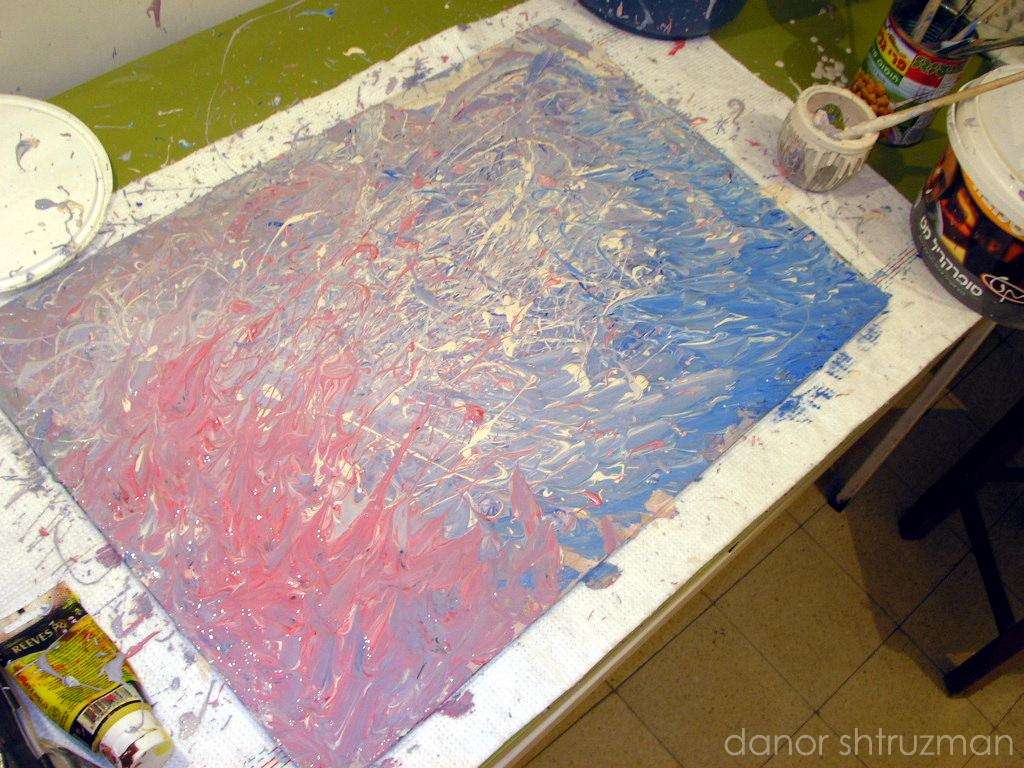What is the main subject of the image? There is a painting on a board in the image. What else can be seen in the image besides the painting? There are objects on a table in the image, and there is a floor visible on the right side bottom of the image. What is located on the right side bottom of the image? There is an object on the right side bottom of the image. Is there any indication of the image's origin or ownership? Yes, there is a watermark in the image. What type of fruit is causing the person in the image to cough? There is no person or fruit present in the image, and therefore no such activity can be observed. 